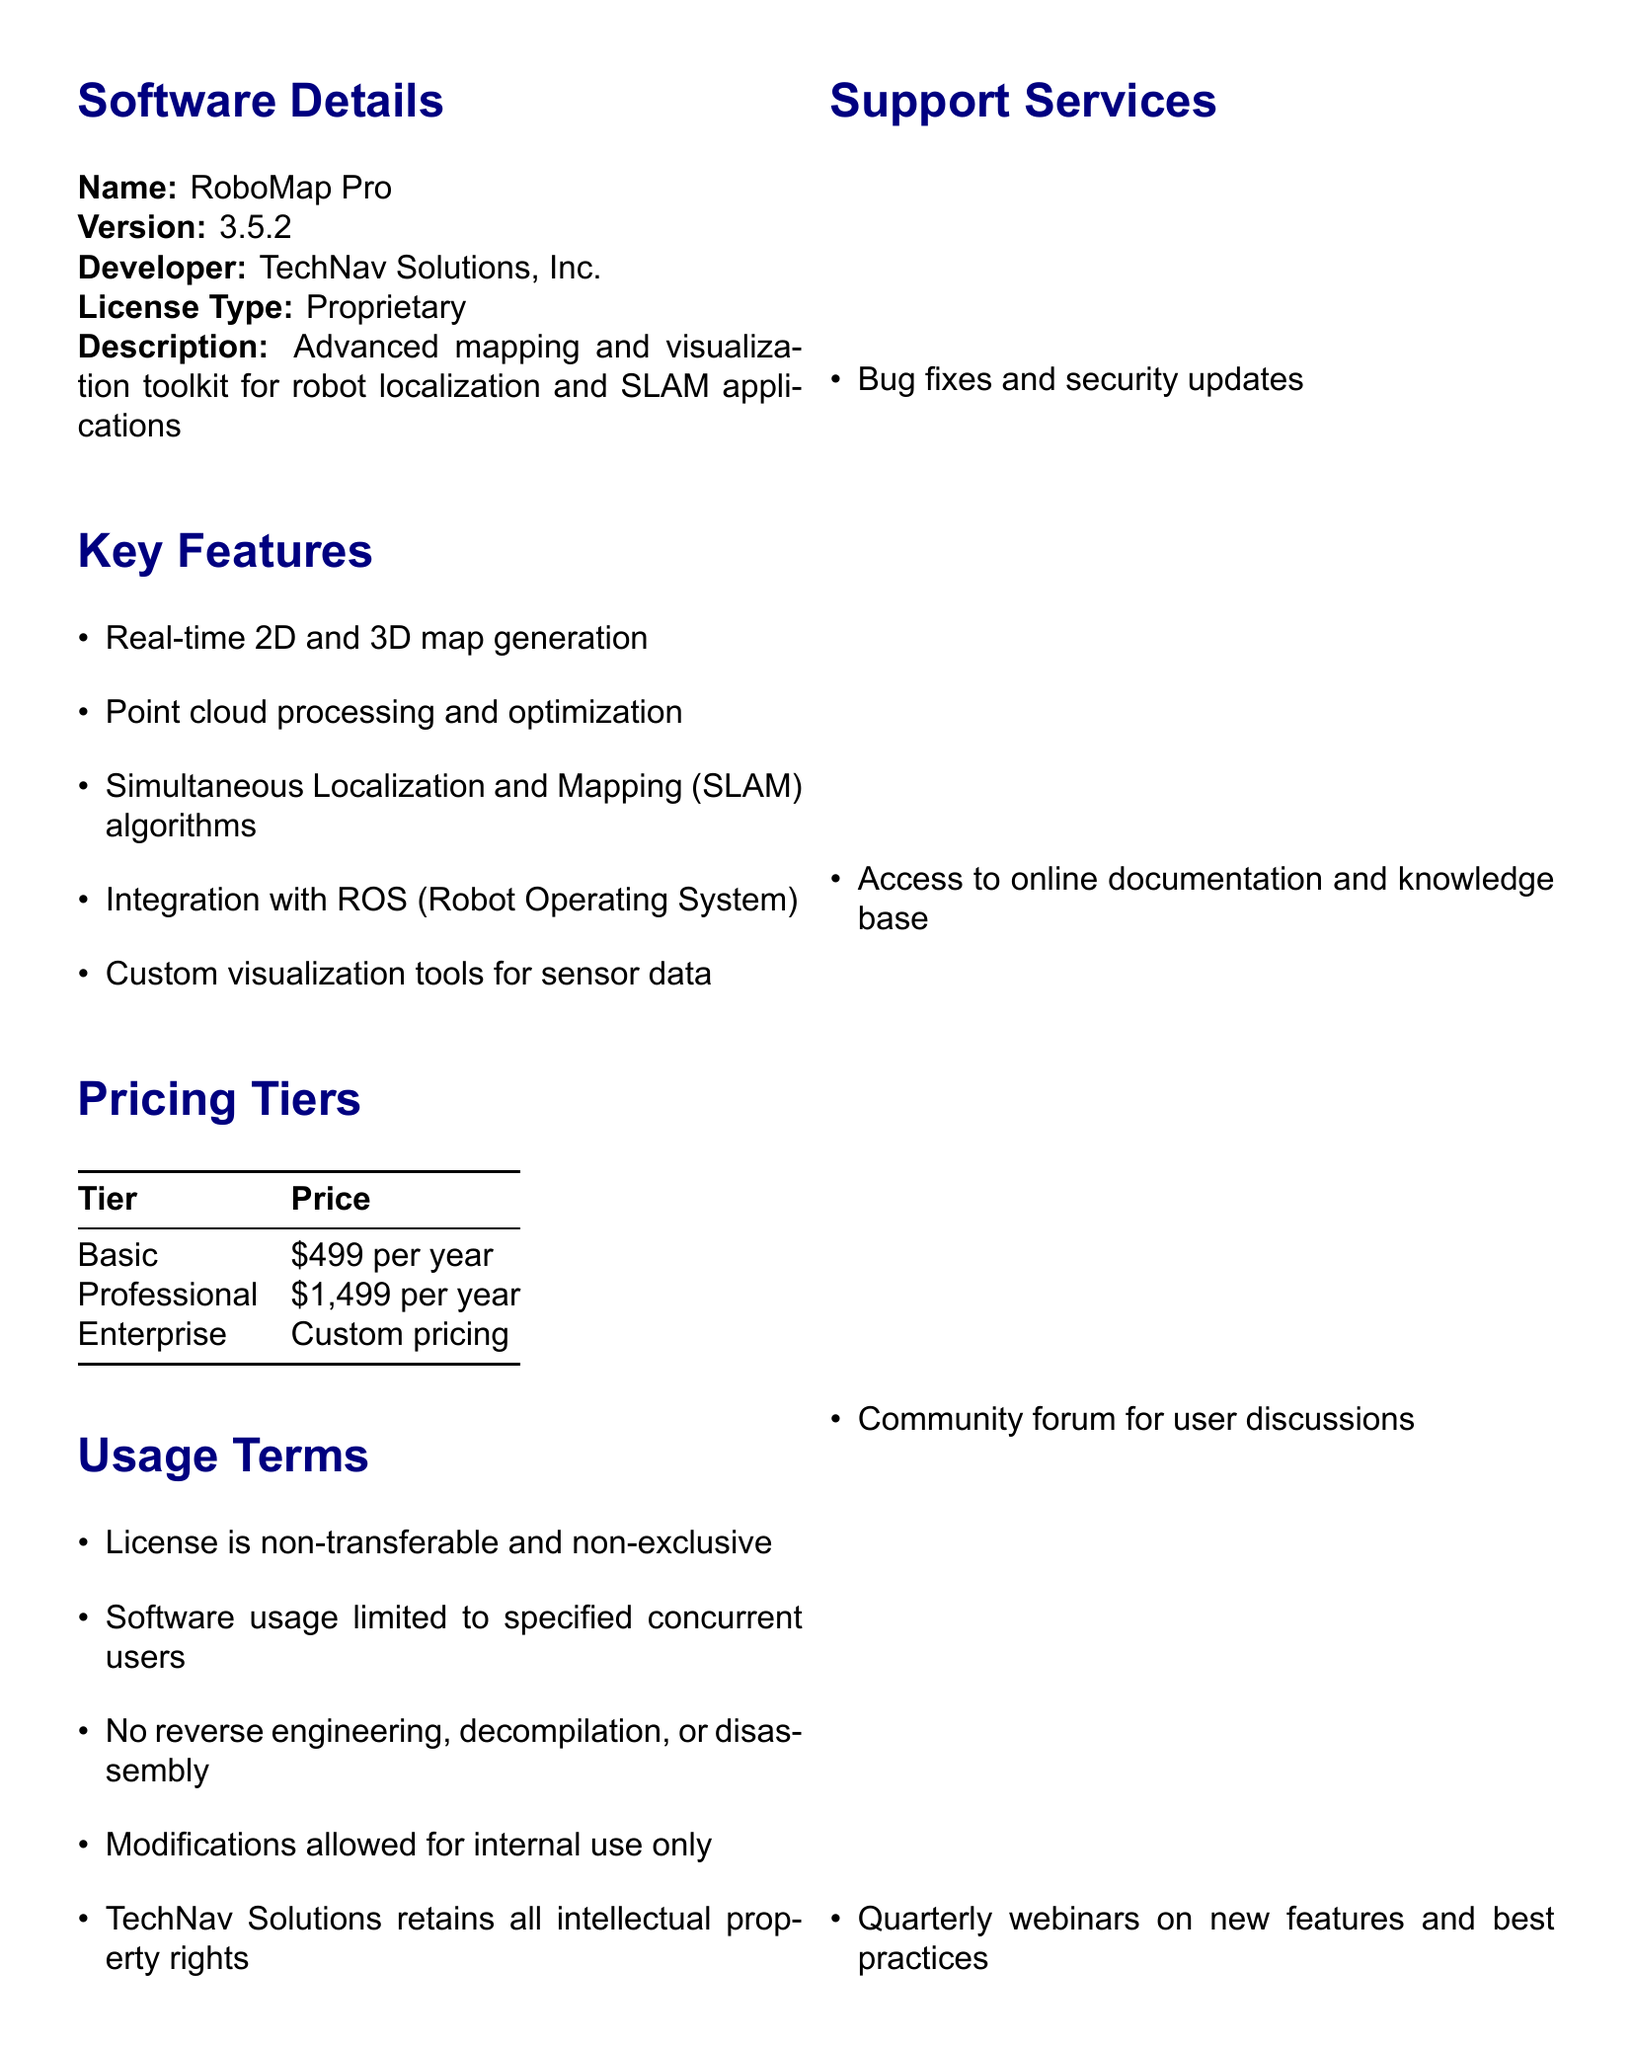What is the name of the software? The name of the software is detailed in the document under "Software Details."
Answer: RoboMap Pro Who is the developer of the software? The developer's name can be found in the "Software Details" section of the document.
Answer: TechNav Solutions, Inc What pricing tier offers on-site training? This information can be inferred from the features listed under the "Enterprise" pricing tier.
Answer: Enterprise What is the price of the Professional tier? The document specifies this pricing in the "Pricing Tiers" section.
Answer: $1,499 per year What is the cancellation policy duration? This policy is mentioned in the "Payment Terms" section of the document.
Answer: 30-day written notice How often are major updates released? This detail is provided in the "Update Policy" section.
Answer: Annually Who retains intellectual property rights? This information is stated under the "Usage Terms" section.
Answer: TechNav Solutions Is a discount available for academic use? This is confirmed in the "Academic Use" section of the document.
Answer: Yes What legal jurisdiction governs the license agreement? The governing law is indicated in the "Legal" section of the document.
Answer: State of California, United States 